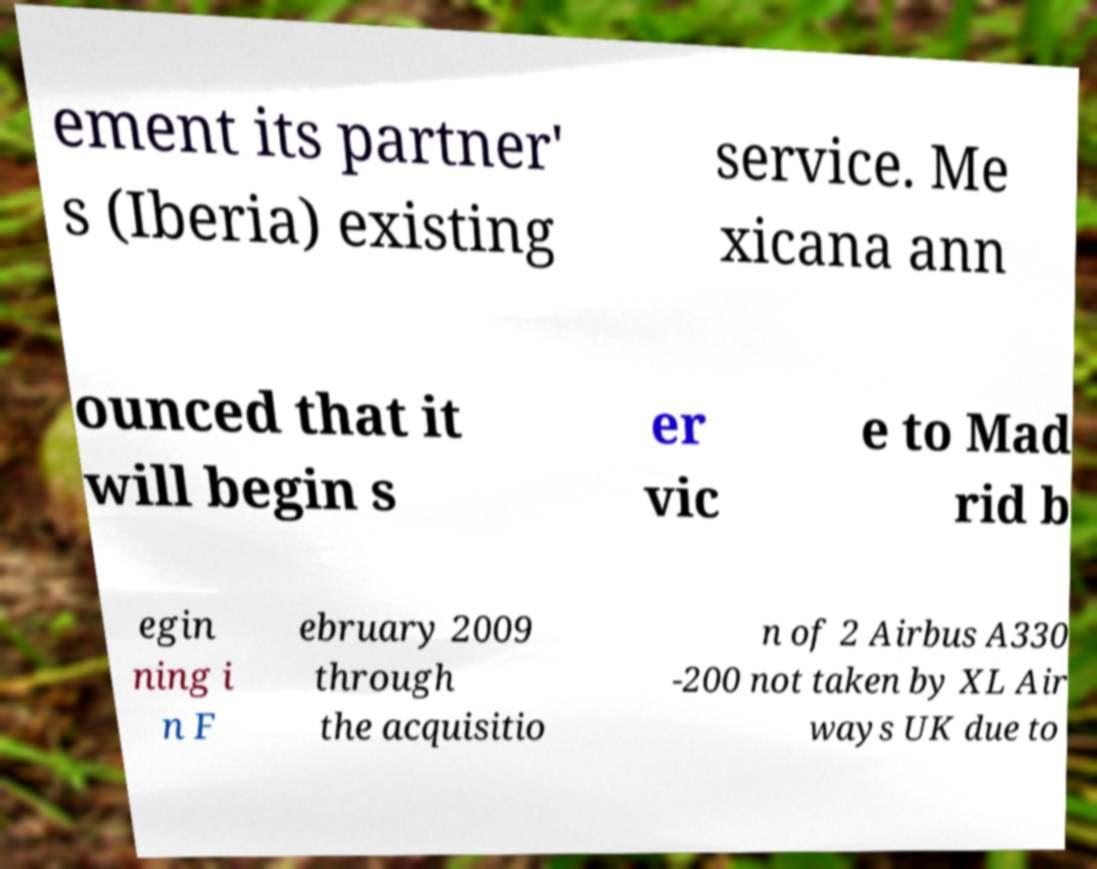There's text embedded in this image that I need extracted. Can you transcribe it verbatim? ement its partner' s (Iberia) existing service. Me xicana ann ounced that it will begin s er vic e to Mad rid b egin ning i n F ebruary 2009 through the acquisitio n of 2 Airbus A330 -200 not taken by XL Air ways UK due to 